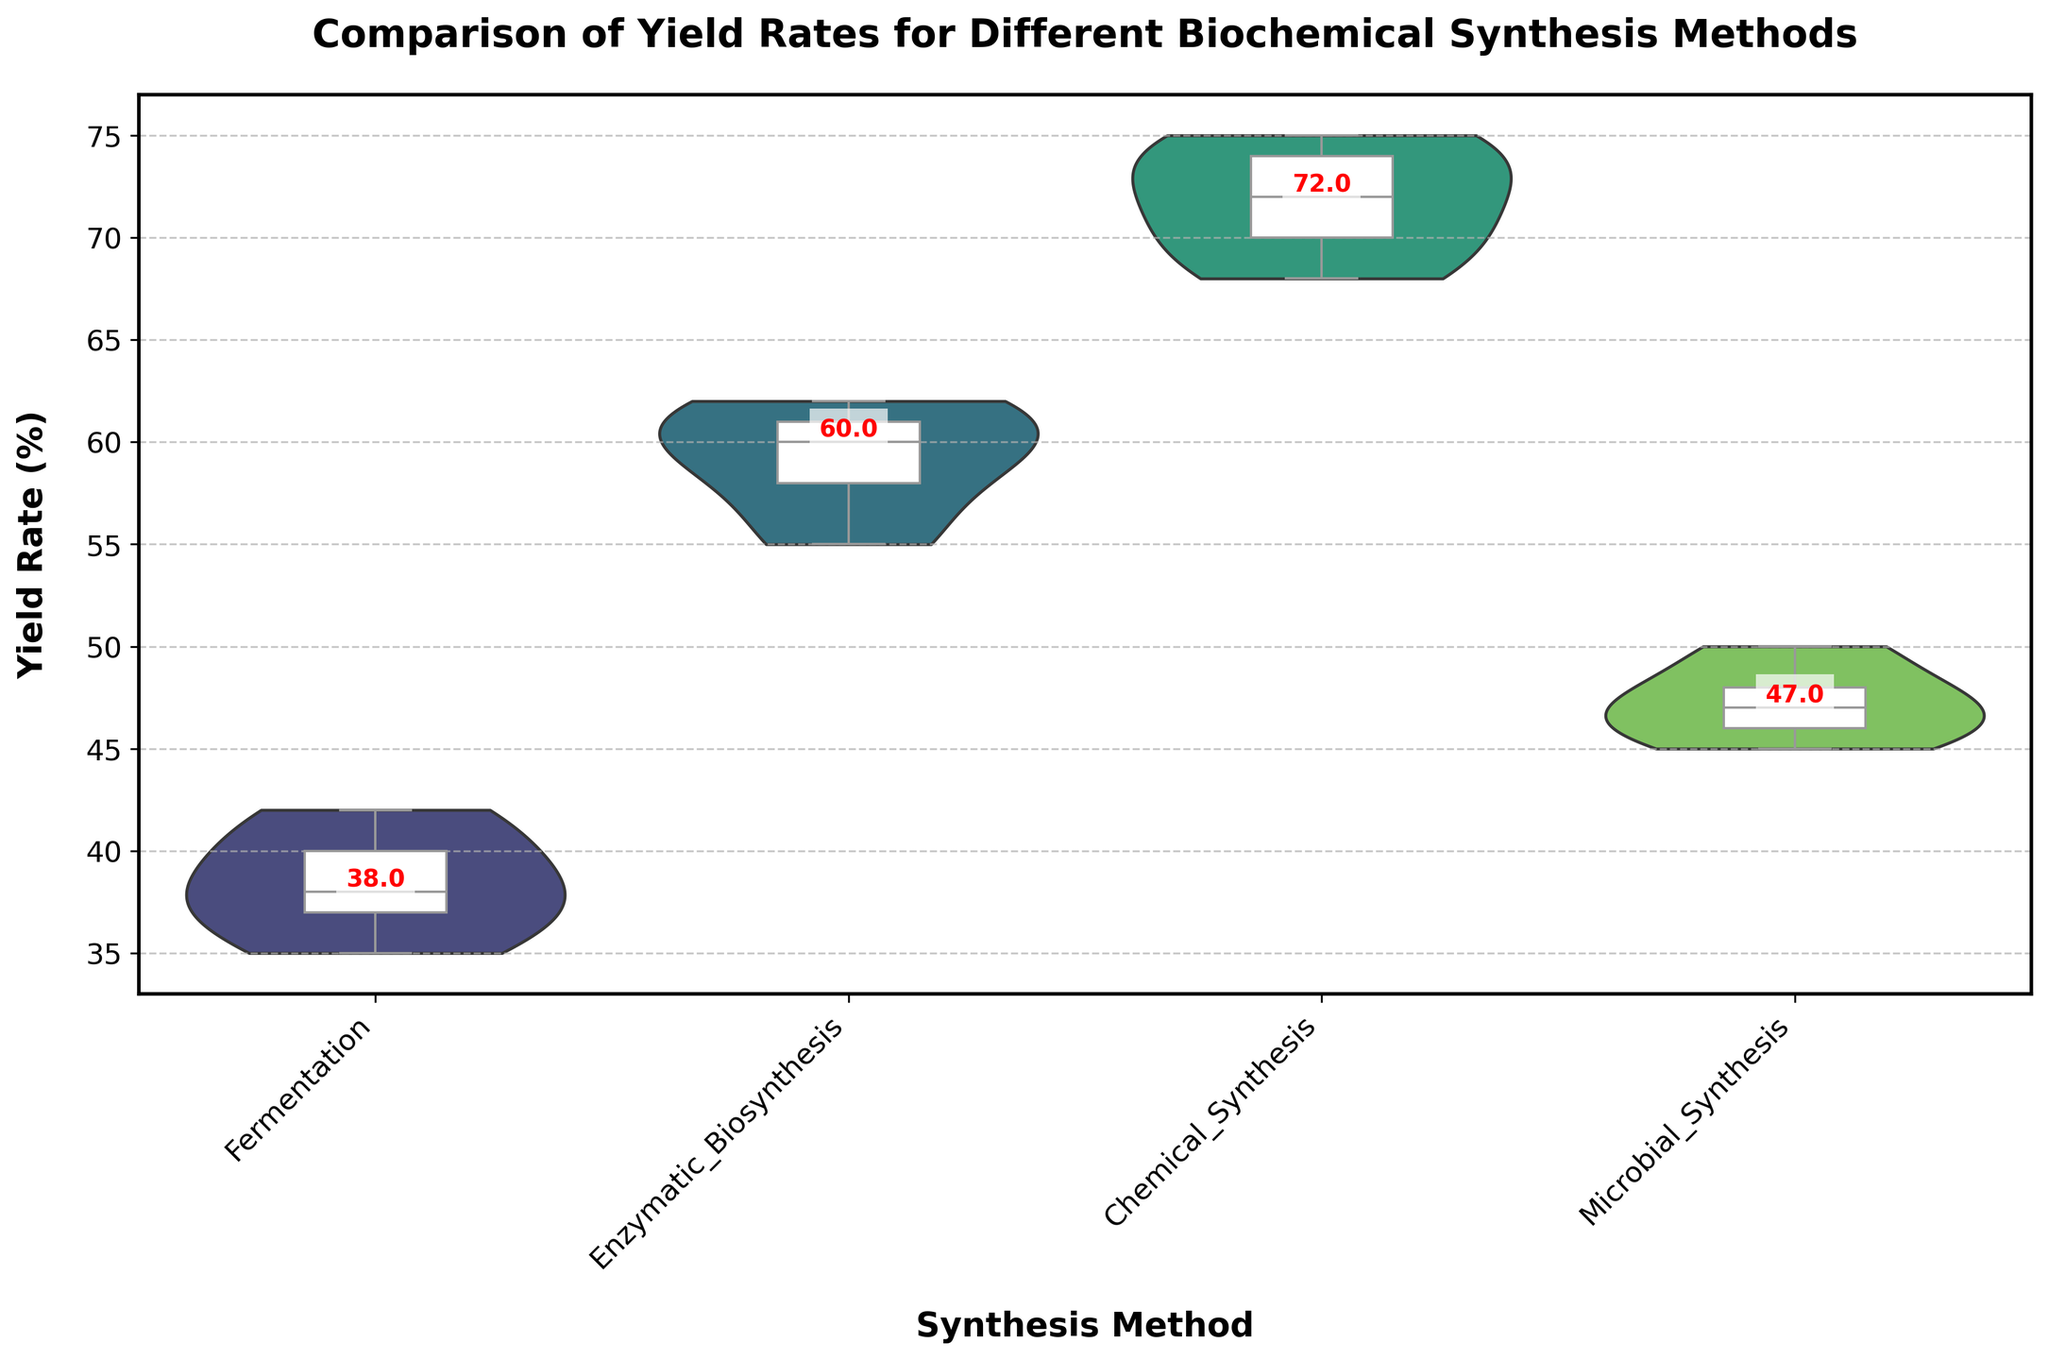What is the title of the figure? The title can be found at the top of the figure, indicating what the figure is about.
Answer: Comparison of Yield Rates for Different Biochemical Synthesis Methods How many synthesis methods are compared in the figure? By looking at the x-axis of the figure, four different synthesis methods are listed.
Answer: Four What is the median yield rate for the Fermentation method? The median value for each method is annotated on the figure. For Fermentation, the annotated median value is visible.
Answer: 38 Which synthesis method has the highest median yield rate? By comparing the annotated median values, Enzymatic Biosynthesis has the highest median yield rate.
Answer: Enzymatic Biosynthesis What is the interquartile range (IQR) for Chemical Synthesis? The IQR is the range between the 25th and 75th percentiles, shown in the box plot. For Chemical Synthesis, this range is between the bottom and top edges of the box.
Answer: 70 to 74 Which synthesis method has the greatest spread in its yield rates? By looking at the width of the violin plots, which indicate the spread of yield rates, Fermentation has the widest spread, showing the most variation in its data.
Answer: Fermentation How do the median yield rates for Fermentation and Microbial Synthesis compare? By looking at the annotated median values for both, Fermentation’s median is 38 while Microbial Synthesis’s median is 47. Microbial Synthesis has a higher median yield rate.
Answer: Microbial Synthesis is higher Is there any overlap in the yield rate distributions of Enzymatic Biosynthesis and Chemical Synthesis? The overlap can be seen in the violin plots if any portion of their distributions intersect. There's a slight overlap visible between the upper end of Enzymatic Biosynthesis and the lower end of Chemical Synthesis.
Answer: Yes What is the range of yield rates for Enzymatic Biosynthesis? The range is derived from the extremes of the violin plot for Enzymatic Biosynthesis, extending approximately from 55 to 62.
Answer: 55 to 62 How does the variability of yield rates compare between Chemical Synthesis and Microbial Synthesis? Variability is indicated by the width of the violin plots. Chemical Synthesis shows less variability with a narrower plot, while Microbial Synthesis shows more variability with a wider plot.
Answer: Microbial Synthesis has more variability 